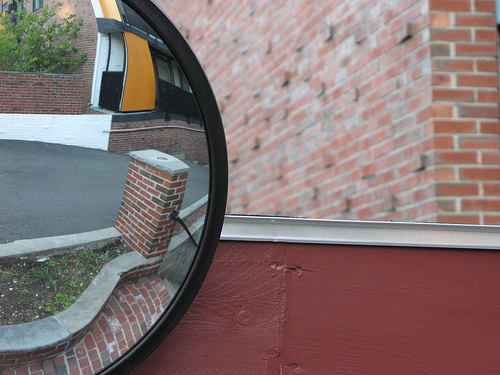<image>
Can you confirm if the mirror is next to the building? Yes. The mirror is positioned adjacent to the building, located nearby in the same general area. 